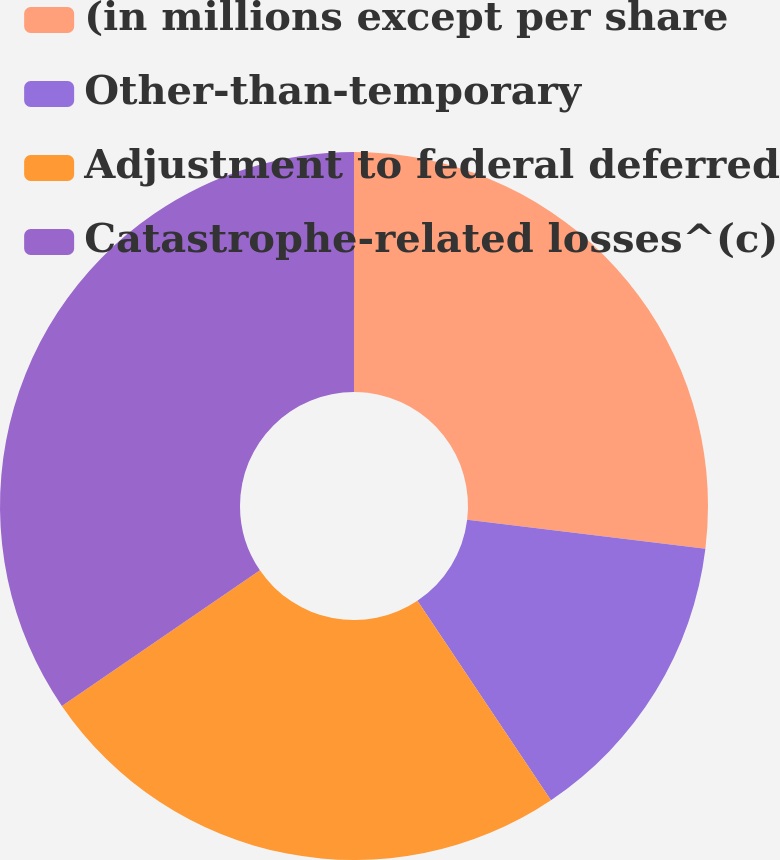Convert chart. <chart><loc_0><loc_0><loc_500><loc_500><pie_chart><fcel>(in millions except per share<fcel>Other-than-temporary<fcel>Adjustment to federal deferred<fcel>Catastrophe-related losses^(c)<nl><fcel>26.93%<fcel>13.68%<fcel>24.84%<fcel>34.55%<nl></chart> 